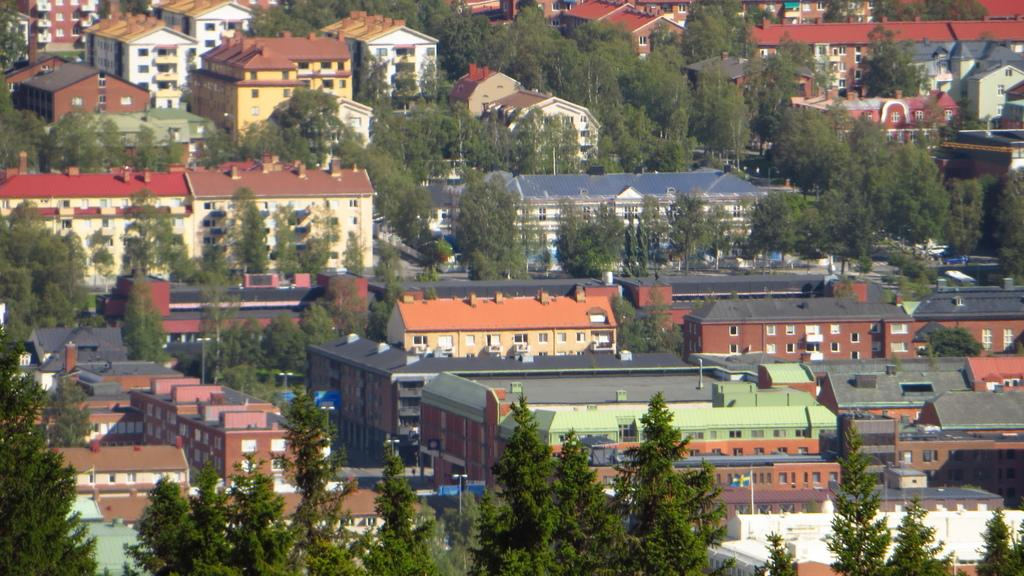What types of structures can be seen in the image? There are buildings and houses in the image. What natural elements are present in the image? There are trees and plants in the image. How many snails can be seen crawling on the buildings in the image? There are no snails visible in the image; it features buildings, houses, trees, and plants. 